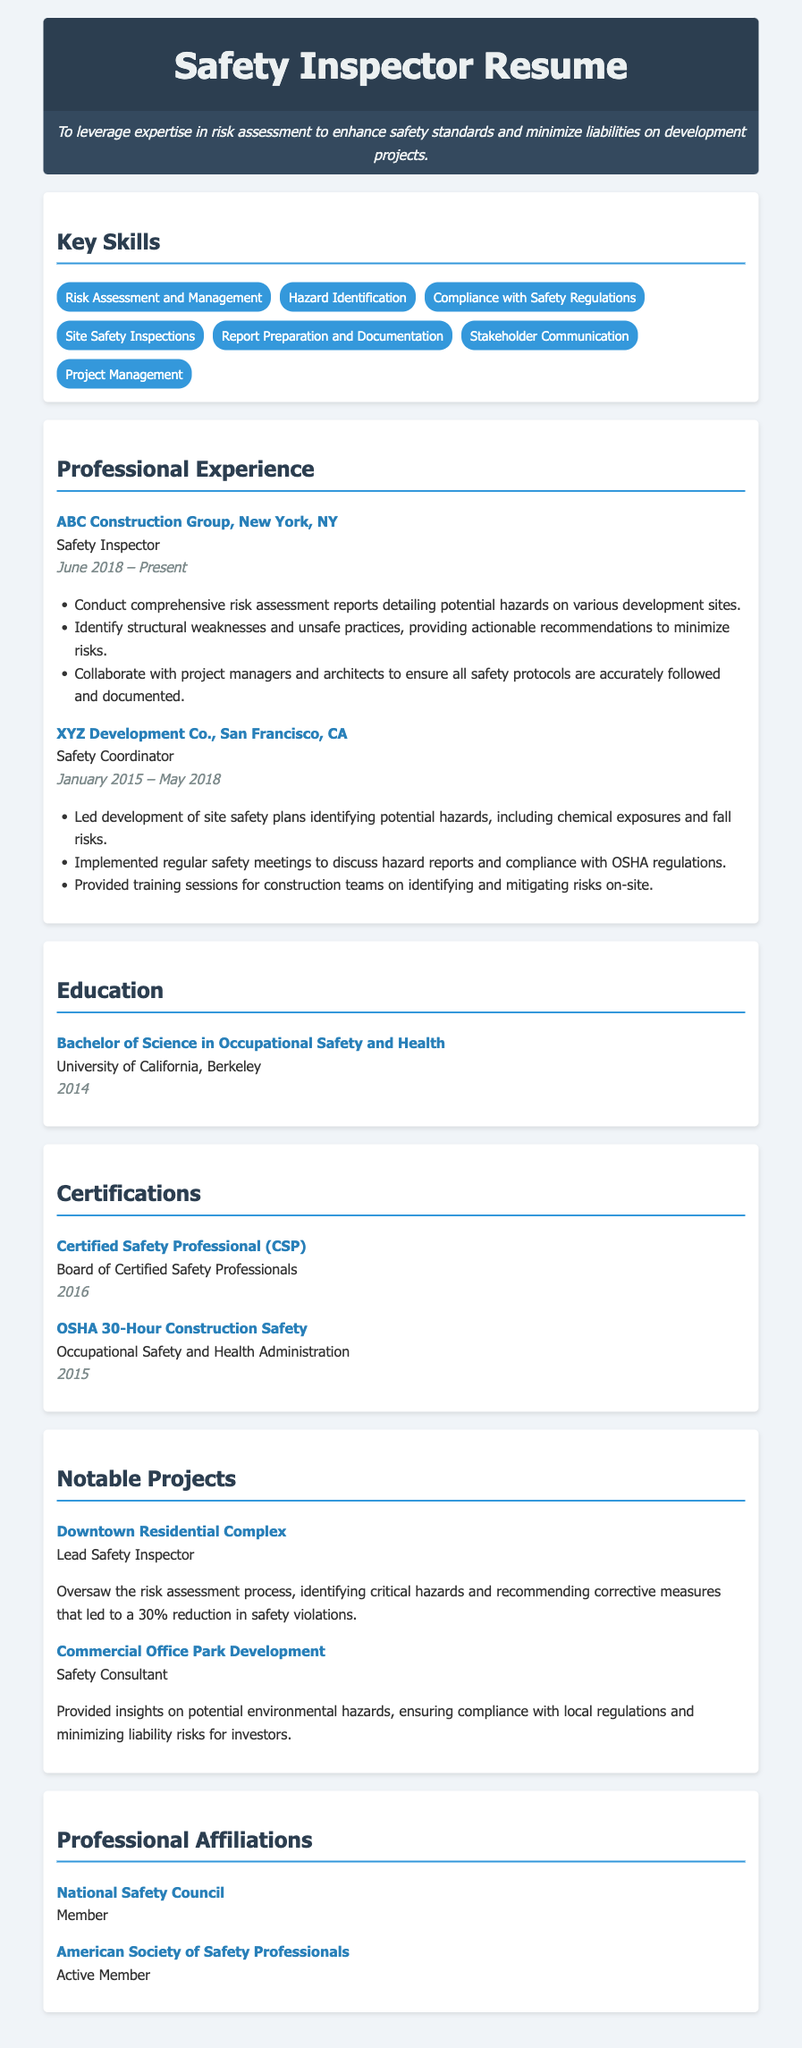What is the current position of the safety inspector? The current position of the safety inspector is stated in the professional experience section.
Answer: Safety Inspector When did the safety inspector start working at ABC Construction Group? The start date is listed in the dates section of the professional experience.
Answer: June 2018 What degree does the safety inspector hold? The degree is mentioned in the education section of the resume.
Answer: Bachelor of Science in Occupational Safety and Health How many certifications does the safety inspector have listed? The number of certifications can be counted in the certifications section of the resume.
Answer: 2 What organization is the safety inspector a member of? The membership is mentioned in the professional affiliations section of the resume.
Answer: National Safety Council What was the role of the safety inspector in the Downtown Residential Complex project? The role can be found in the notable projects section.
Answer: Lead Safety Inspector What percentage reduction in safety violations was achieved in the Downtown Residential Complex project? This information is provided in the description of the notable project.
Answer: 30% Which regulatory body provided the OSHA certification? The institution that issued the certification is mentioned in the certification section.
Answer: Occupational Safety and Health Administration What was one of the key skills listed on the resume? Skills can be found in the key skills section of the resume.
Answer: Risk Assessment and Management 